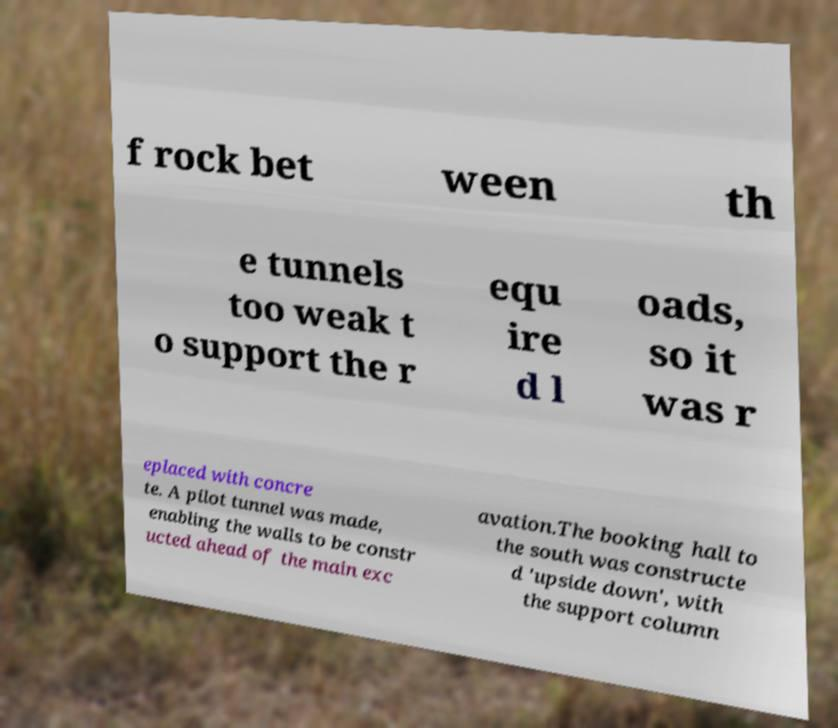Please read and relay the text visible in this image. What does it say? f rock bet ween th e tunnels too weak t o support the r equ ire d l oads, so it was r eplaced with concre te. A pilot tunnel was made, enabling the walls to be constr ucted ahead of the main exc avation.The booking hall to the south was constructe d 'upside down', with the support column 